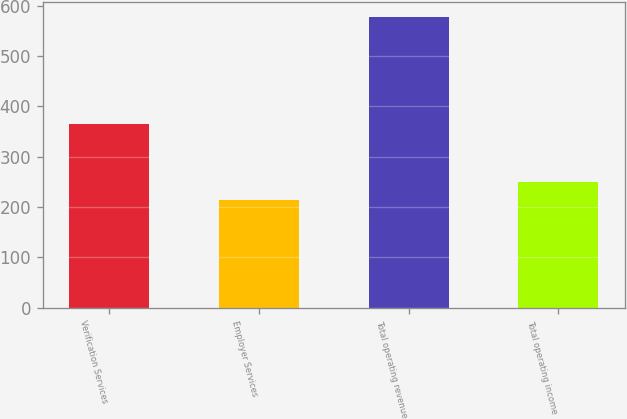Convert chart. <chart><loc_0><loc_0><loc_500><loc_500><bar_chart><fcel>Verification Services<fcel>Employer Services<fcel>Total operating revenue<fcel>Total operating income<nl><fcel>364.4<fcel>213.3<fcel>577.7<fcel>249.74<nl></chart> 